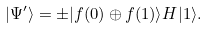<formula> <loc_0><loc_0><loc_500><loc_500>| \Psi ^ { \prime } \rangle = \pm | f ( 0 ) \oplus f ( 1 ) \rangle H | 1 \rangle .</formula> 